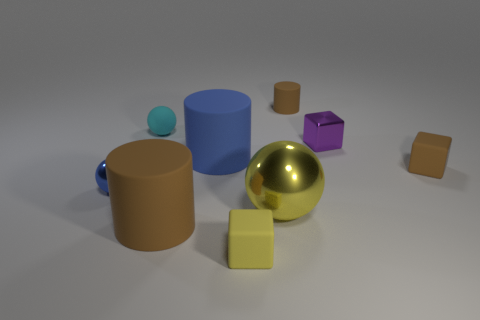Add 1 yellow balls. How many objects exist? 10 Subtract all cylinders. How many objects are left? 6 Add 7 small cyan spheres. How many small cyan spheres are left? 8 Add 8 small brown metal objects. How many small brown metal objects exist? 8 Subtract 1 yellow spheres. How many objects are left? 8 Subtract all tiny red rubber blocks. Subtract all small purple shiny objects. How many objects are left? 8 